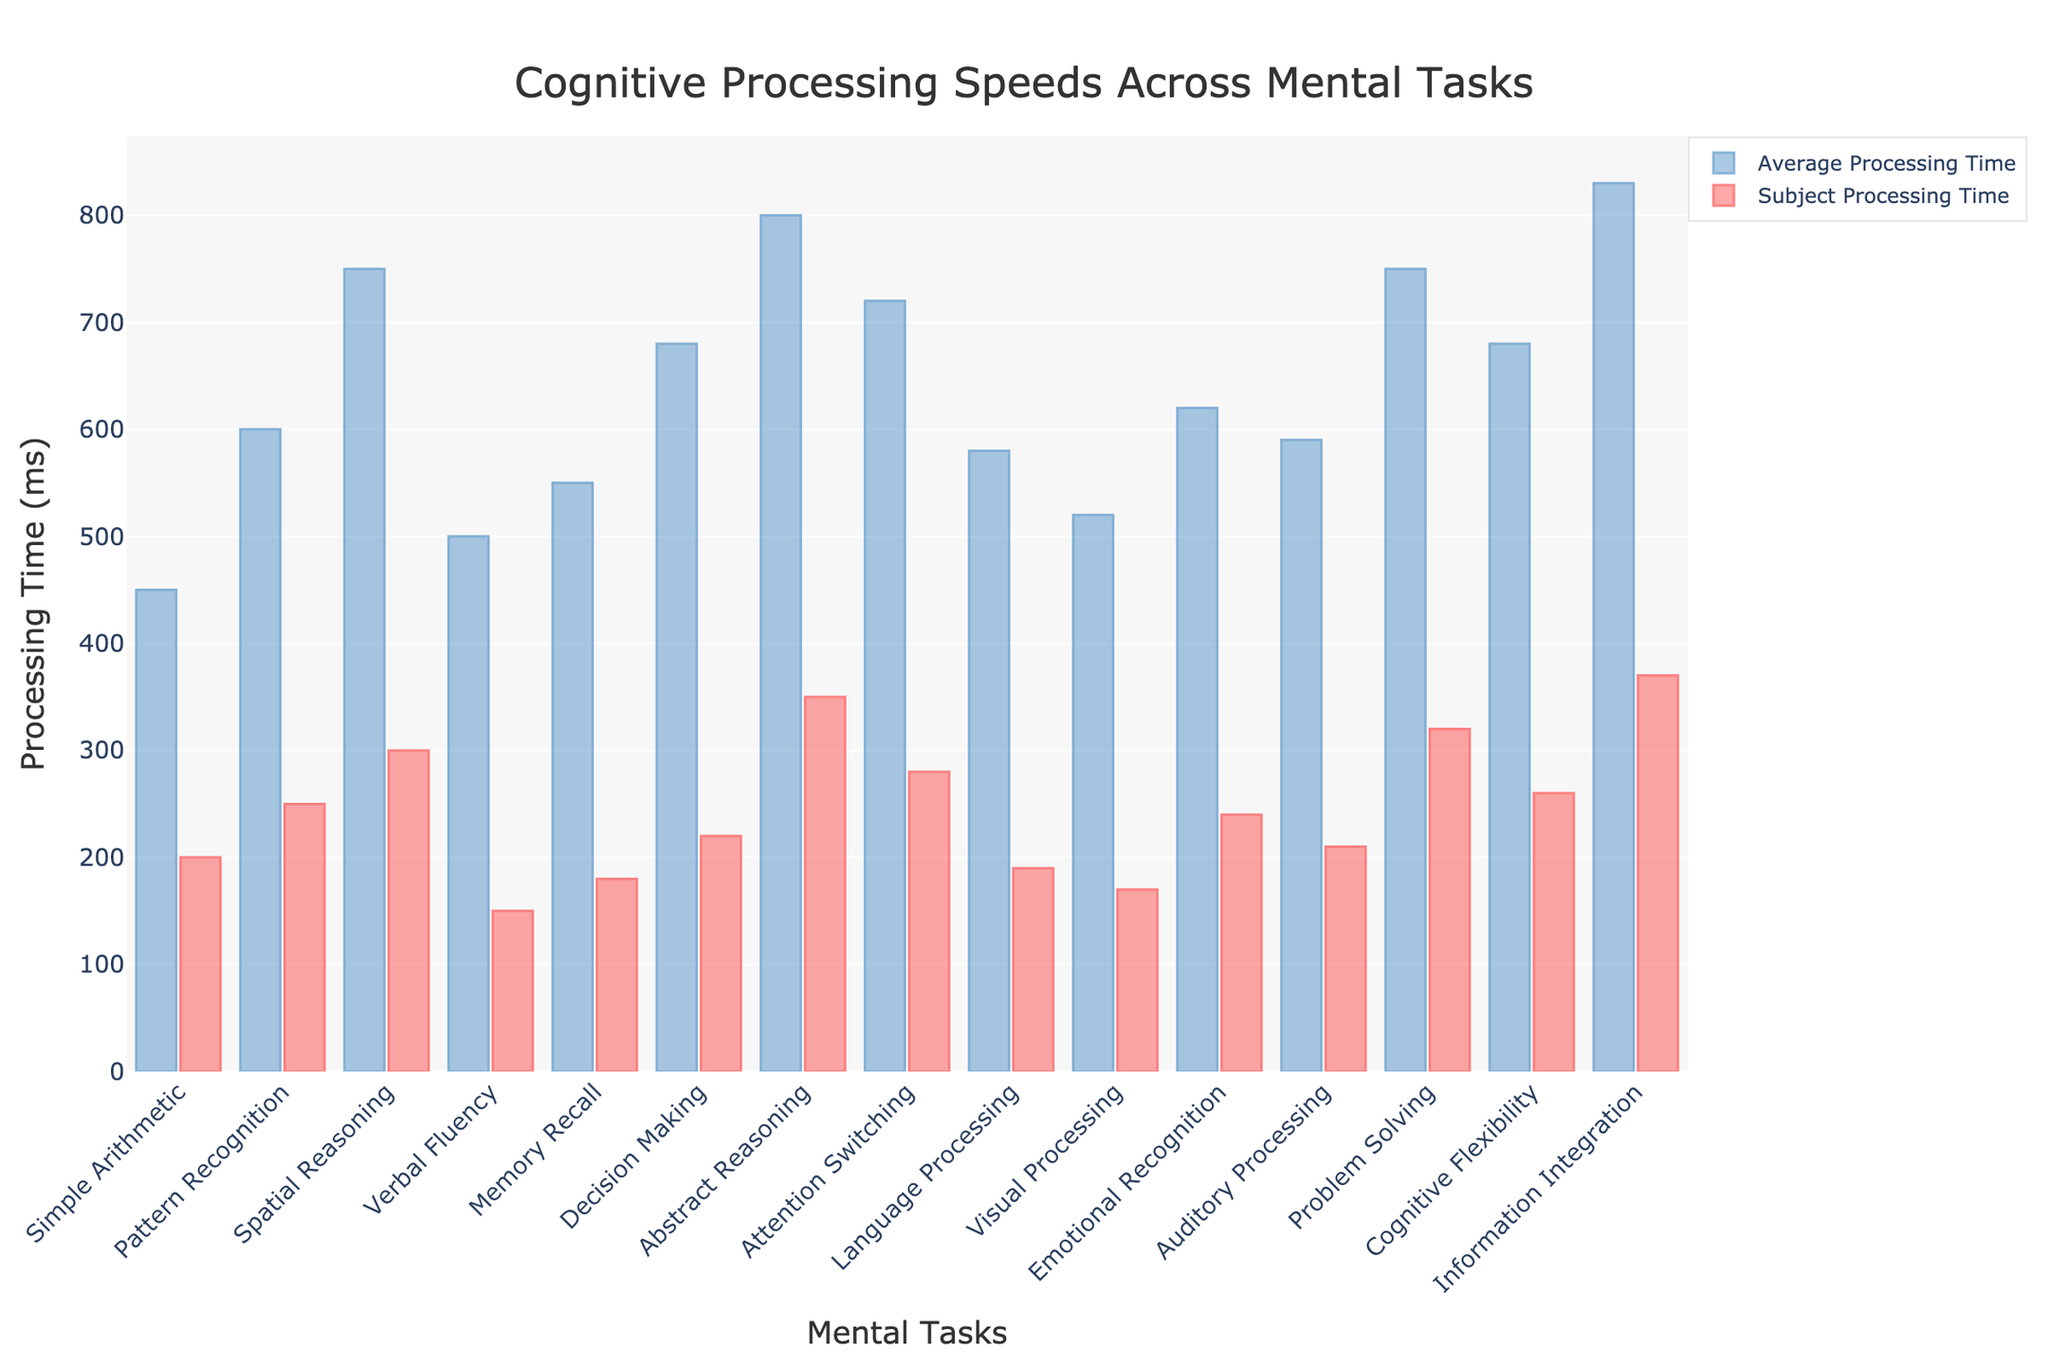What's the task with the shortest subject processing time? Look at all the red bars and identify the shortest one. The shortest red bar corresponds to "Verbal Fluency"
Answer: Verbal Fluency What's the difference in processing time between the subject and the average for "Problem Solving"? Subtract the "Subject Processing Time (ms)" from the "Average Processing Time (ms)" for "Problem Solving": 750 - 320 = 430 ms
Answer: 430 ms Which task shows the greatest improvement in processing time for the subject compared to the average? Calculate the differences between "Average Processing Time (ms)" and "Subject Processing Time (ms)" for all tasks and find the largest difference. "Abstract Reasoning" shows the greatest improvement: 800 - 350 = 450 ms
Answer: Abstract Reasoning How much longer on average does "Information Integration" take compared to "Language Processing" for the subject? Subtract the "Subject Processing Time (ms)" between "Information Integration" and "Language Processing": 370 - 190 = 180 ms
Answer: 180 ms Which tasks have subject processing times less than 300 ms? Identify all red bars with values less than 300. These tasks are "Simple Arithmetic", "Pattern Recognition", "Spatial Reasoning", "Verbal Fluency", "Memory Recall", "Attention Switching", "Language Processing", "Visual Processing", "Emotional Recognition", "Auditory Processing", and "Cognitive Flexibility"
Answer: Simple Arithmetic, Pattern Recognition, Spatial Reasoning, Verbal Fluency, Memory Recall, Attention Switching, Language Processing, Visual Processing, Emotional Recognition, Auditory Processing, Cognitive Flexibility 